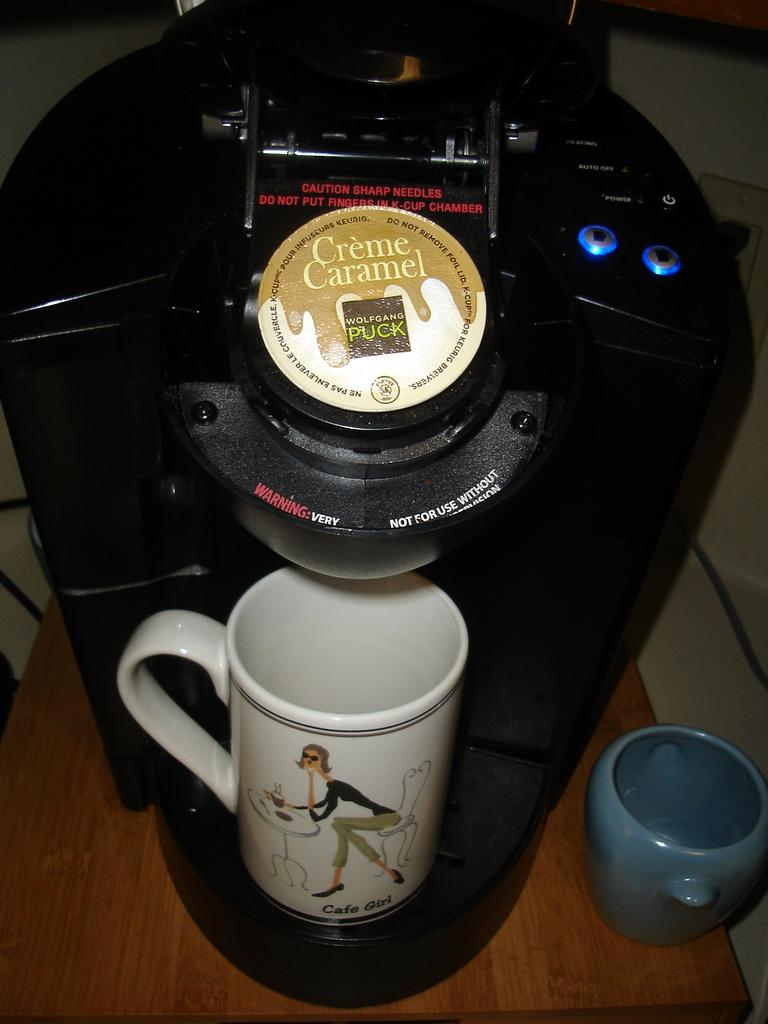<image>
Present a compact description of the photo's key features. Pod coffee marker with a creme caramel pod inside. 